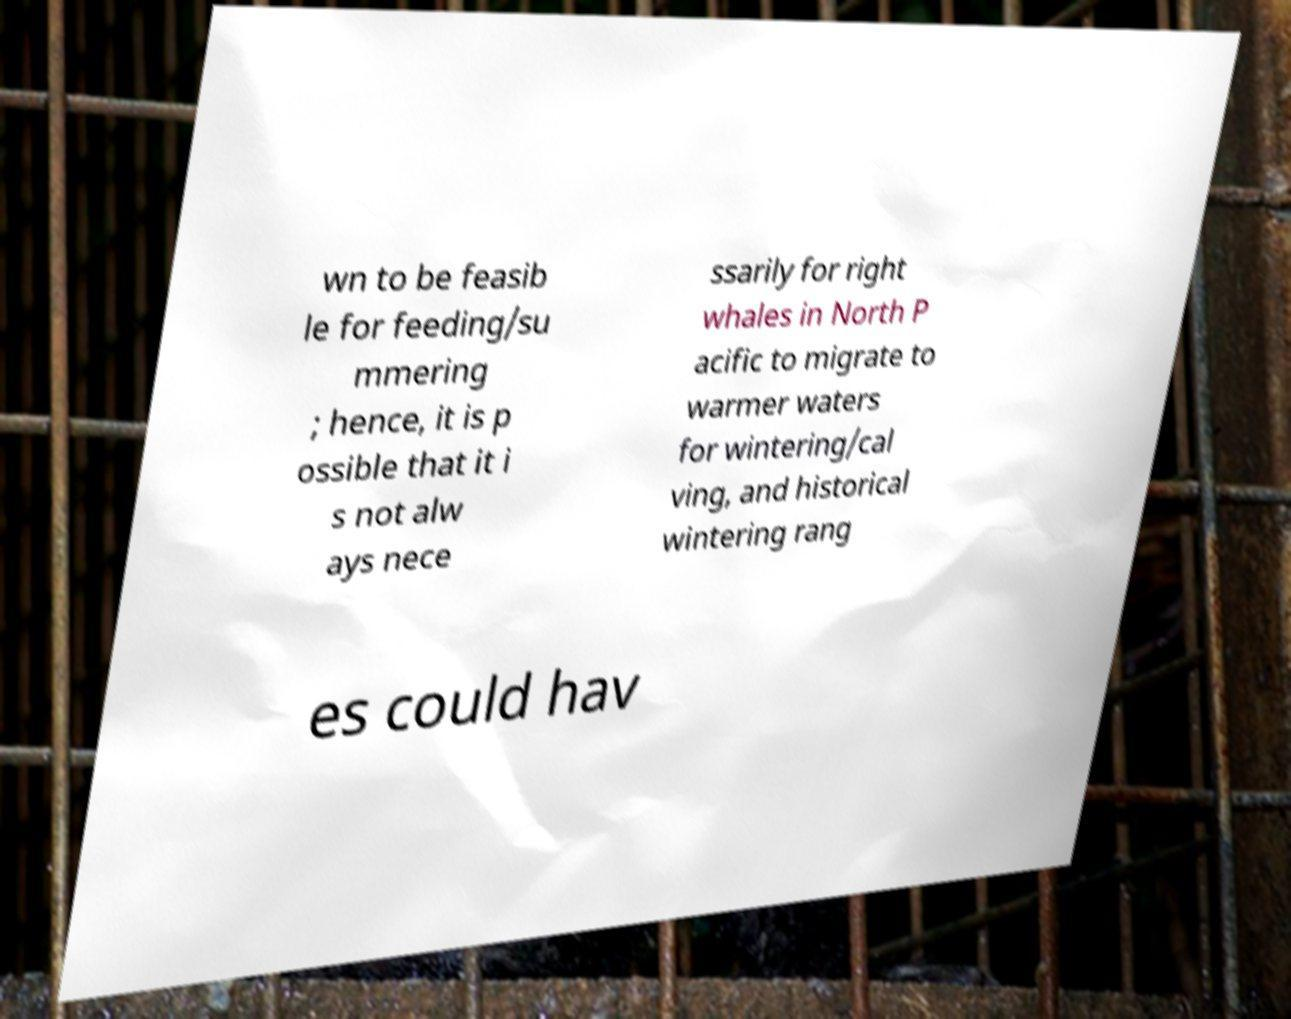Could you assist in decoding the text presented in this image and type it out clearly? wn to be feasib le for feeding/su mmering ; hence, it is p ossible that it i s not alw ays nece ssarily for right whales in North P acific to migrate to warmer waters for wintering/cal ving, and historical wintering rang es could hav 